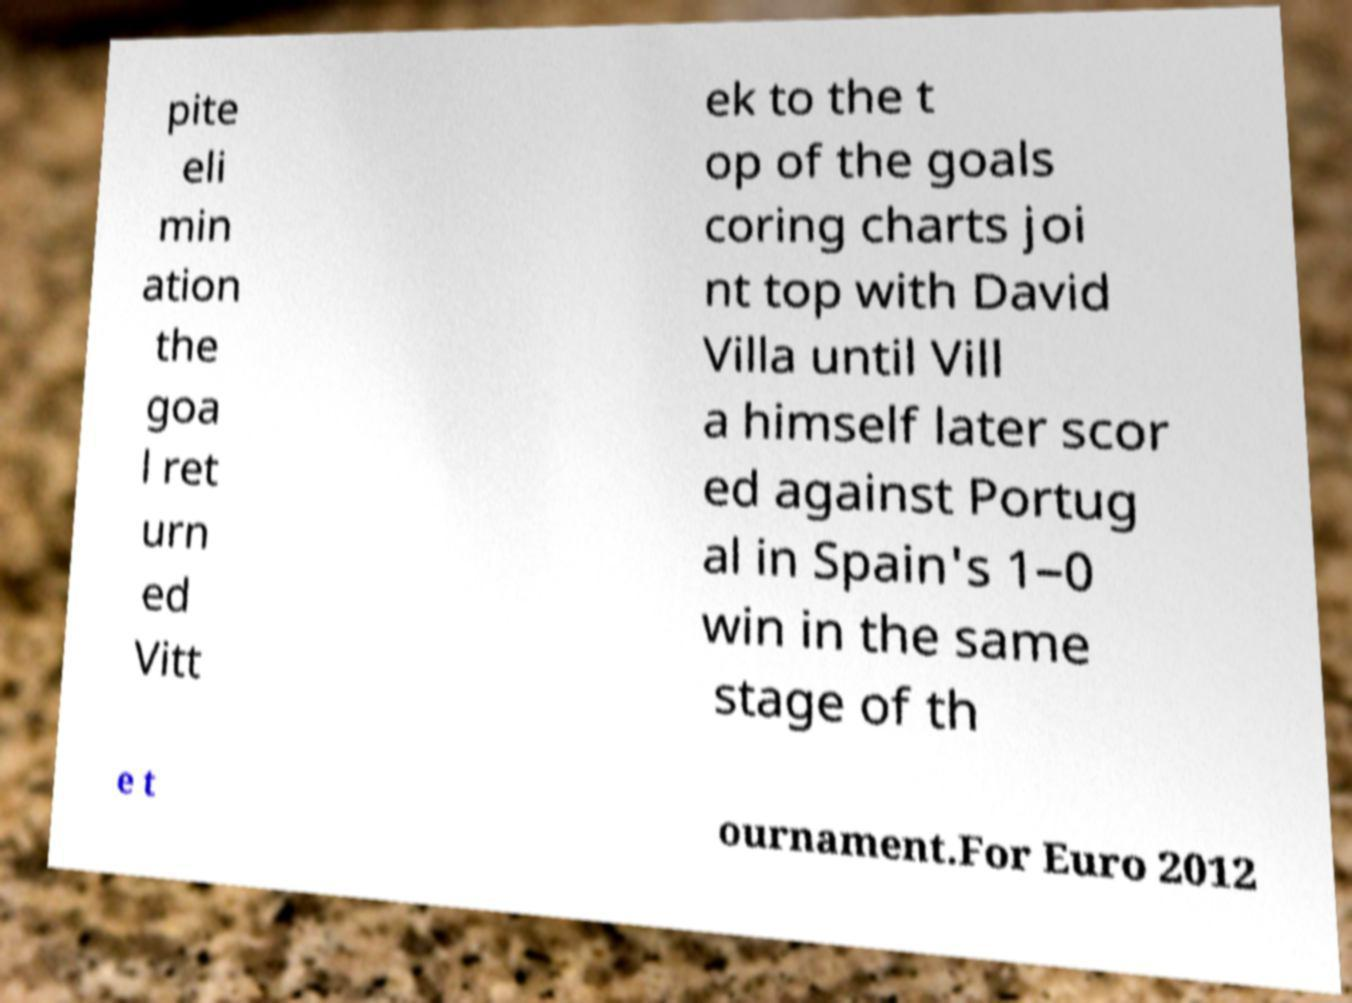What messages or text are displayed in this image? I need them in a readable, typed format. pite eli min ation the goa l ret urn ed Vitt ek to the t op of the goals coring charts joi nt top with David Villa until Vill a himself later scor ed against Portug al in Spain's 1–0 win in the same stage of th e t ournament.For Euro 2012 